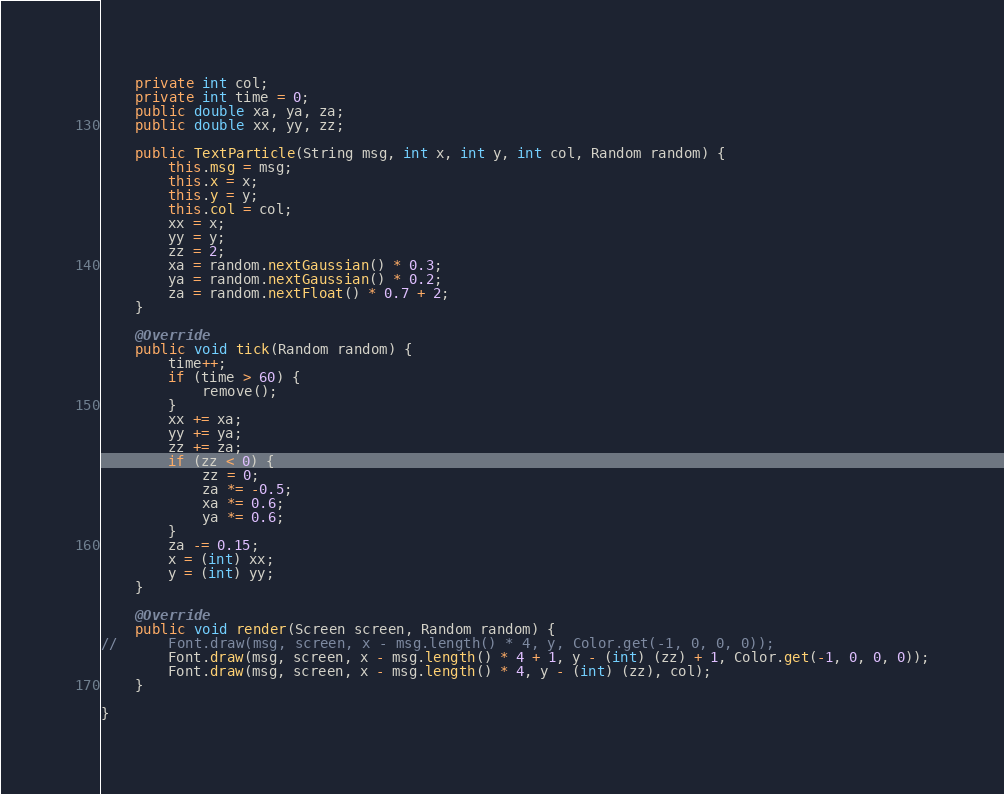<code> <loc_0><loc_0><loc_500><loc_500><_Java_>	private int col;
	private int time = 0;
	public double xa, ya, za;
	public double xx, yy, zz;

	public TextParticle(String msg, int x, int y, int col, Random random) {
		this.msg = msg;
		this.x = x;
		this.y = y;
		this.col = col;
		xx = x;
		yy = y;
		zz = 2;
		xa = random.nextGaussian() * 0.3;
		ya = random.nextGaussian() * 0.2;
		za = random.nextFloat() * 0.7 + 2;
	}

	@Override
	public void tick(Random random) {
		time++;
		if (time > 60) {
			remove();
		}
		xx += xa;
		yy += ya;
		zz += za;
		if (zz < 0) {
			zz = 0;
			za *= -0.5;
			xa *= 0.6;
			ya *= 0.6;
		}
		za -= 0.15;
		x = (int) xx;
		y = (int) yy;
	}

	@Override
	public void render(Screen screen, Random random) {
//		Font.draw(msg, screen, x - msg.length() * 4, y, Color.get(-1, 0, 0, 0));
		Font.draw(msg, screen, x - msg.length() * 4 + 1, y - (int) (zz) + 1, Color.get(-1, 0, 0, 0));
		Font.draw(msg, screen, x - msg.length() * 4, y - (int) (zz), col);
	}

}
</code> 